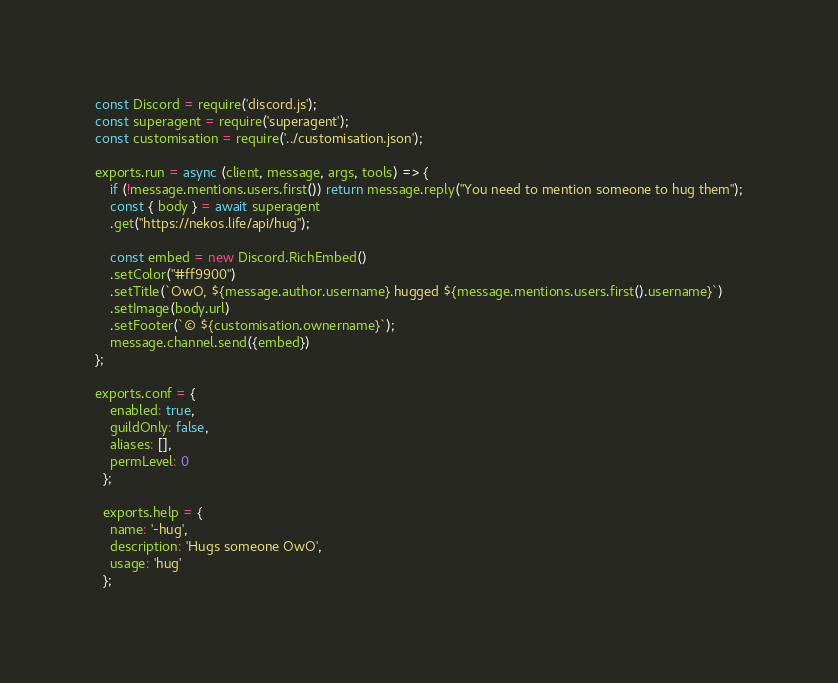<code> <loc_0><loc_0><loc_500><loc_500><_JavaScript_>const Discord = require('discord.js');
const superagent = require('superagent');
const customisation = require('../customisation.json');

exports.run = async (client, message, args, tools) => {
    if (!message.mentions.users.first()) return message.reply("You need to mention someone to hug them");
    const { body } = await superagent
    .get("https://nekos.life/api/hug");
    
    const embed = new Discord.RichEmbed()
    .setColor("#ff9900")
    .setTitle(`OwO, ${message.author.username} hugged ${message.mentions.users.first().username}`)
    .setImage(body.url) 
    .setFooter(`© ${customisation.ownername}`);
    message.channel.send({embed})
};

exports.conf = {
    enabled: true,
    guildOnly: false,
    aliases: [],
    permLevel: 0
  };
  
  exports.help = {
    name: '-hug',
    description: 'Hugs someone OwO',
    usage: 'hug'
  };</code> 